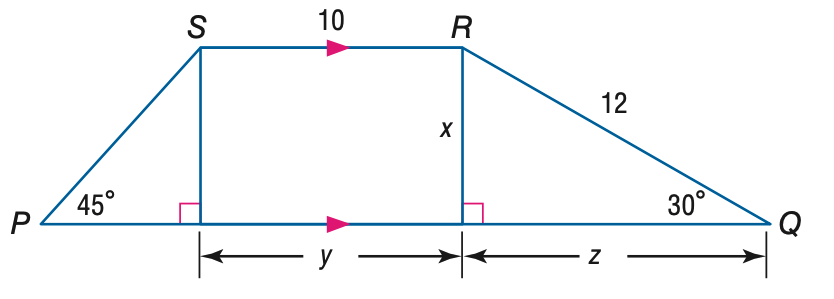Answer the mathemtical geometry problem and directly provide the correct option letter.
Question: Find z.
Choices: A: 2 \sqrt { 3 } B: 6 C: 6 \sqrt { 2 } D: 6 \sqrt { 3 } D 